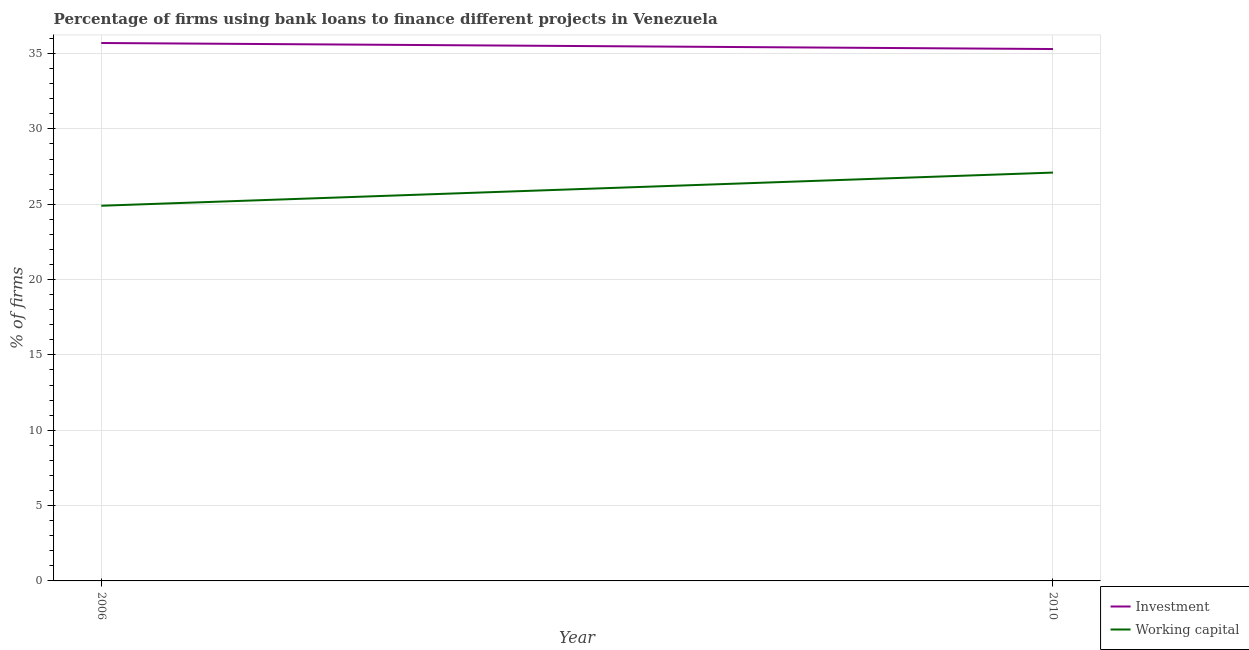What is the percentage of firms using banks to finance investment in 2010?
Make the answer very short. 35.3. Across all years, what is the maximum percentage of firms using banks to finance working capital?
Offer a terse response. 27.1. Across all years, what is the minimum percentage of firms using banks to finance working capital?
Provide a succinct answer. 24.9. In which year was the percentage of firms using banks to finance working capital minimum?
Ensure brevity in your answer.  2006. What is the total percentage of firms using banks to finance investment in the graph?
Keep it short and to the point. 71. What is the difference between the percentage of firms using banks to finance working capital in 2006 and that in 2010?
Provide a succinct answer. -2.2. What is the difference between the percentage of firms using banks to finance investment in 2006 and the percentage of firms using banks to finance working capital in 2010?
Your answer should be compact. 8.6. What is the average percentage of firms using banks to finance investment per year?
Give a very brief answer. 35.5. In the year 2006, what is the difference between the percentage of firms using banks to finance investment and percentage of firms using banks to finance working capital?
Keep it short and to the point. 10.8. In how many years, is the percentage of firms using banks to finance investment greater than 16 %?
Your answer should be compact. 2. What is the ratio of the percentage of firms using banks to finance working capital in 2006 to that in 2010?
Provide a succinct answer. 0.92. Is the percentage of firms using banks to finance investment in 2006 less than that in 2010?
Your response must be concise. No. Does the percentage of firms using banks to finance investment monotonically increase over the years?
Your response must be concise. No. Is the percentage of firms using banks to finance investment strictly greater than the percentage of firms using banks to finance working capital over the years?
Give a very brief answer. Yes. Is the percentage of firms using banks to finance investment strictly less than the percentage of firms using banks to finance working capital over the years?
Give a very brief answer. No. How many lines are there?
Provide a succinct answer. 2. Where does the legend appear in the graph?
Your response must be concise. Bottom right. How are the legend labels stacked?
Provide a short and direct response. Vertical. What is the title of the graph?
Your answer should be very brief. Percentage of firms using bank loans to finance different projects in Venezuela. Does "Female labor force" appear as one of the legend labels in the graph?
Offer a very short reply. No. What is the label or title of the Y-axis?
Provide a short and direct response. % of firms. What is the % of firms in Investment in 2006?
Your answer should be compact. 35.7. What is the % of firms of Working capital in 2006?
Your answer should be very brief. 24.9. What is the % of firms in Investment in 2010?
Keep it short and to the point. 35.3. What is the % of firms in Working capital in 2010?
Give a very brief answer. 27.1. Across all years, what is the maximum % of firms in Investment?
Your answer should be very brief. 35.7. Across all years, what is the maximum % of firms of Working capital?
Give a very brief answer. 27.1. Across all years, what is the minimum % of firms of Investment?
Give a very brief answer. 35.3. Across all years, what is the minimum % of firms of Working capital?
Your answer should be compact. 24.9. What is the total % of firms of Working capital in the graph?
Your answer should be compact. 52. What is the difference between the % of firms in Investment in 2006 and that in 2010?
Make the answer very short. 0.4. What is the difference between the % of firms in Working capital in 2006 and that in 2010?
Keep it short and to the point. -2.2. What is the difference between the % of firms of Investment in 2006 and the % of firms of Working capital in 2010?
Keep it short and to the point. 8.6. What is the average % of firms of Investment per year?
Keep it short and to the point. 35.5. In the year 2006, what is the difference between the % of firms of Investment and % of firms of Working capital?
Your response must be concise. 10.8. What is the ratio of the % of firms in Investment in 2006 to that in 2010?
Ensure brevity in your answer.  1.01. What is the ratio of the % of firms in Working capital in 2006 to that in 2010?
Your answer should be compact. 0.92. What is the difference between the highest and the second highest % of firms in Investment?
Offer a very short reply. 0.4. What is the difference between the highest and the second highest % of firms in Working capital?
Make the answer very short. 2.2. What is the difference between the highest and the lowest % of firms in Investment?
Make the answer very short. 0.4. What is the difference between the highest and the lowest % of firms of Working capital?
Keep it short and to the point. 2.2. 